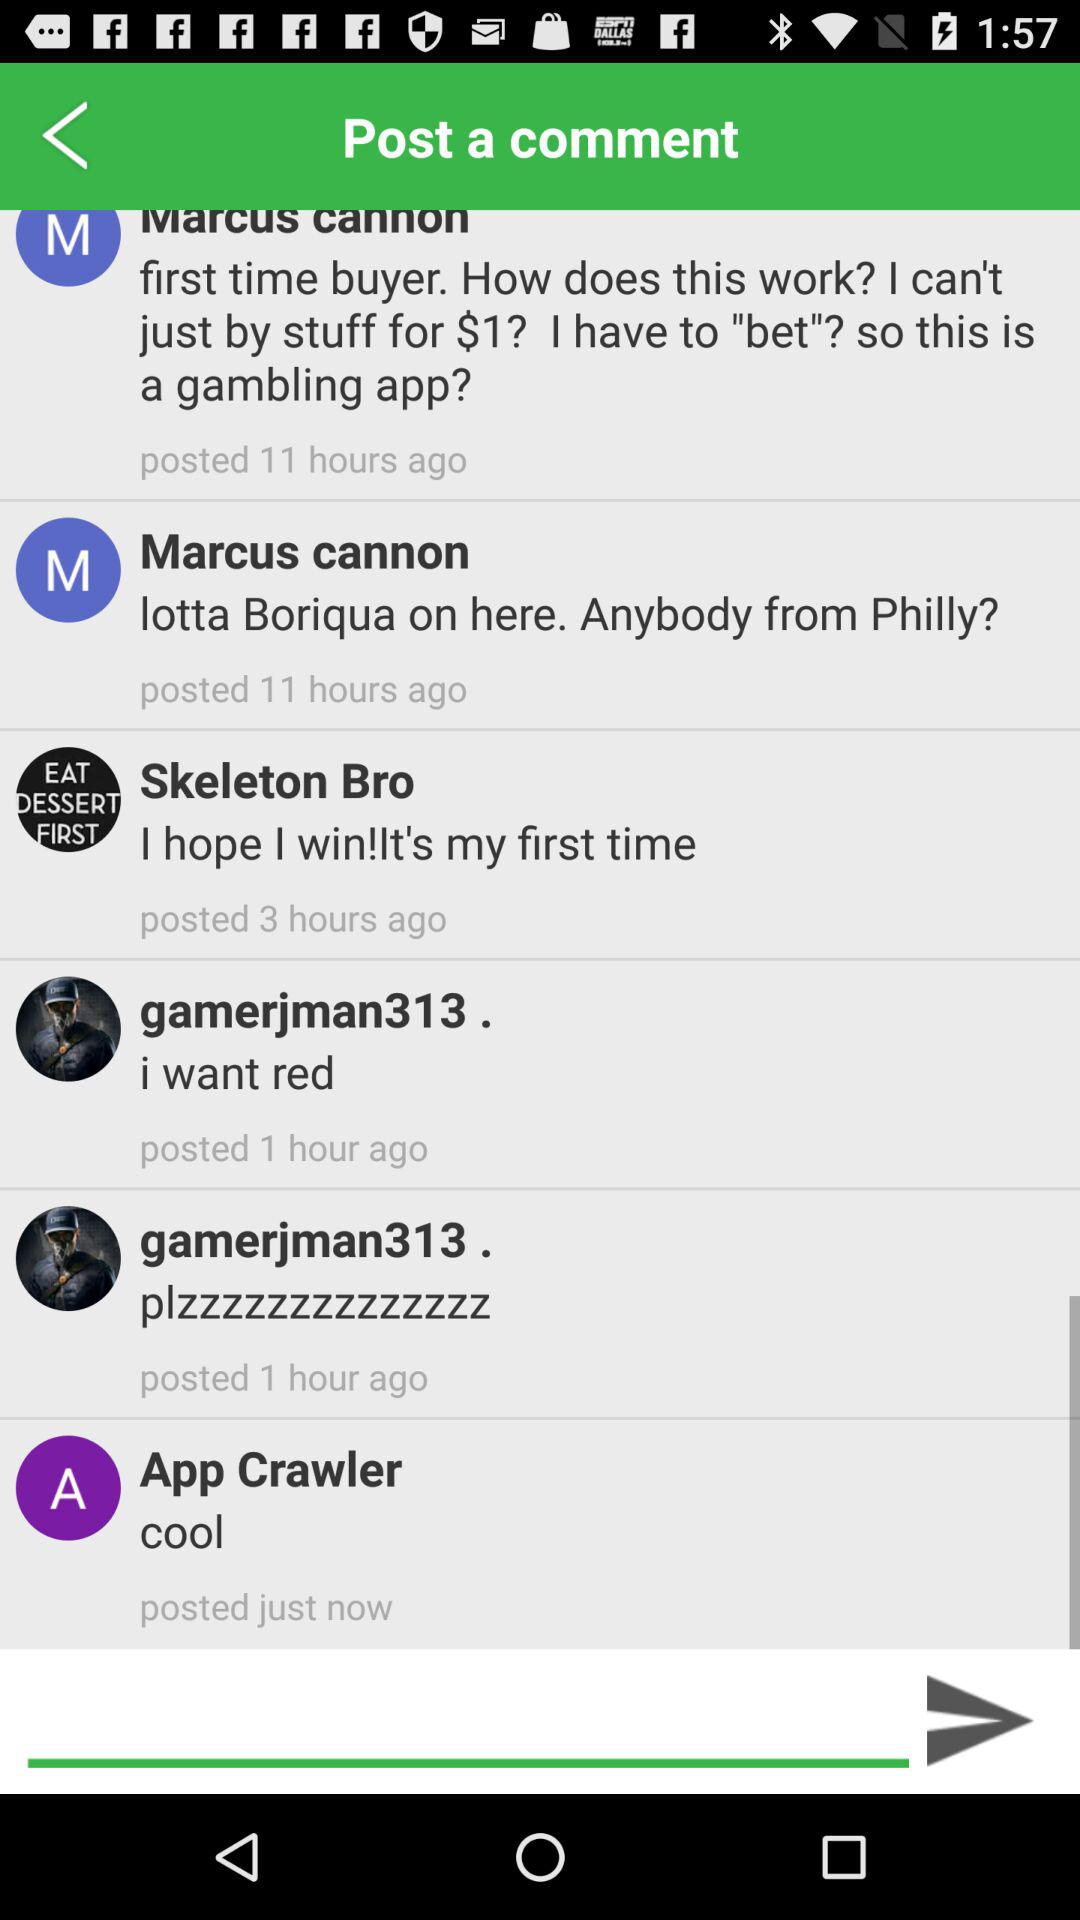When did Marcus Cannon post the comment? Marcus Cannon posted the comment 11 hours ago. 